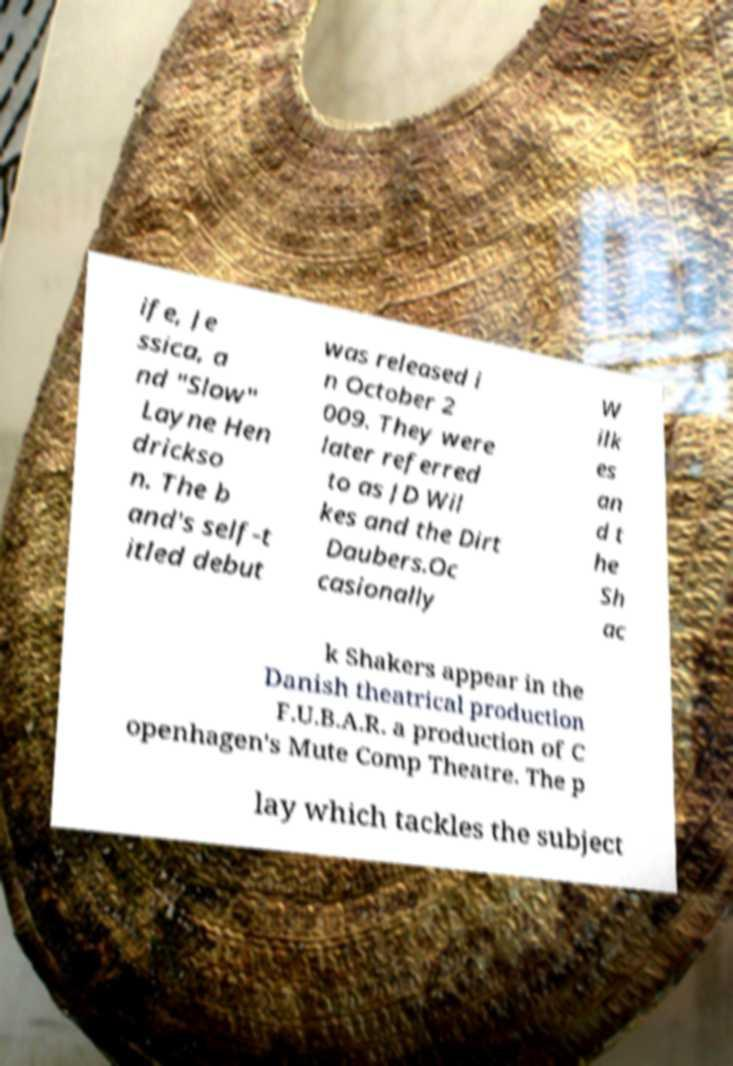What messages or text are displayed in this image? I need them in a readable, typed format. ife, Je ssica, a nd "Slow" Layne Hen drickso n. The b and's self-t itled debut was released i n October 2 009. They were later referred to as JD Wil kes and the Dirt Daubers.Oc casionally W ilk es an d t he Sh ac k Shakers appear in the Danish theatrical production F.U.B.A.R. a production of C openhagen's Mute Comp Theatre. The p lay which tackles the subject 